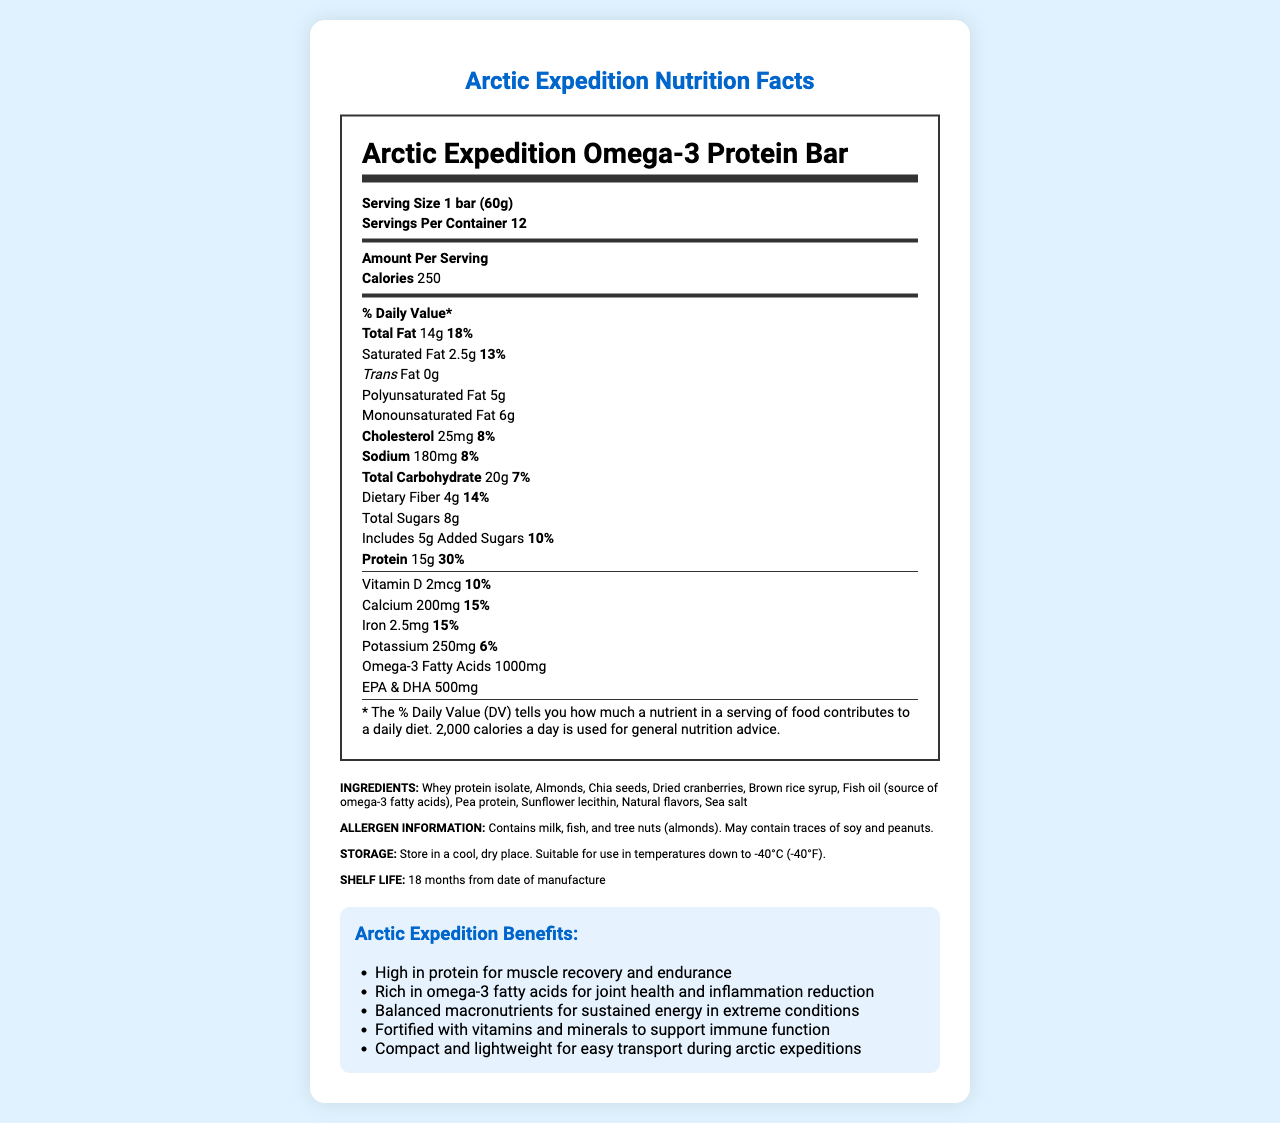what is the serving size of the Arctic Expedition Omega-3 Protein Bar? The serving size is specified right at the top of the nutrition label under the product name.
Answer: 1 bar (60g) how many servings are there per container? The number of servings per container is explicitly noted near the serving size on the nutrition label.
Answer: 12 how many calories are in one serving? The calories per serving are listed under the "Amount Per Serving" section.
Answer: 250 what is the amount of protein in a single protein bar? The protein amount is provided in the "Amount Per Serving" section and is indicated as 15g.
Answer: 15g what is the shelf life of the Arctic Expedition Omega-3 Protein Bar? The shelf life is stated in the storage and shelf life section of the document.
Answer: 18 months from date of manufacture which of the following is NOT an ingredient in the protein bar? A. Almonds B. Chia seeds C. Peanuts D. Dried cranberries The ingredients list includes almonds, chia seeds, and dried cranberries, but not peanuts.
Answer: C. Peanuts how much omega-3 fatty acids does one bar contain? The amount of omega-3 fatty acids is listed in the nutrition label under the "Amount Per Serving" section.
Answer: 1000mg what is the main source of omega-3 fatty acids in the bar? A. Chia seeds B. Fish oil C. Almonds D. Pea protein Fish oil is explicitly mentioned as the source of omega-3 fatty acids in the ingredients list.
Answer: B. Fish oil can this protein bar be stored in temperatures as low as -40°C? The storage instructions specify that the bar is suitable for use in temperatures down to -40°C.
Answer: Yes is this protein bar suitable for someone with a tree nut allergy? The allergen information indicates that the product contains tree nuts (almonds), making it unsuitable for someone with a tree nut allergy.
Answer: No summarize the main features of the Arctic Expedition Omega-3 Protein Bar as presented in the document. The document provides comprehensive information about the product's nutritional content, ingredients, shelf life, storage instructions, and allergen information, emphasizing its suitability for harsh arctic conditions and benefits such as muscle recovery, sustained energy, and inflammation reduction.
Answer: The Arctic Expedition Omega-3 Protein Bar is designed for arctic expeditions, offering a rich source of protein (15g per bar) and omega-3 fatty acids (1000mg per bar). It includes a balanced macronutrient profile, dietary fiber, and is fortified with vitamins and minerals to support immune function. The bar is made of whey protein isolate, almonds, chia seeds, dried cranberries, and fish oil. It is suitable for extreme temperatures down to -40°C and has a shelf life of 18 months. The product also contains allergens such as milk, fish, and tree nuts. how many grams of dietary fiber are in one serving? The amount of dietary fiber per serving is listed in the nutrition label.
Answer: 4g which of the following benefits is NOT mentioned in the document? A. High in protein for muscle recovery B. Rich in antioxidants C. Balanced macronutrients for energy D. Fortified with vitamins and minerals The benefits section of the document does not mention antioxidants; it does, however, list benefits related to protein, macronutrients, and vitamins and minerals.
Answer: B. Rich in antioxidants are there any trans fats in the protein bar? The document specifies that the protein bar contains 0g of trans fats.
Answer: No is the daily value of monounsaturated fats specified in the document? While the amount of monounsaturated fat (6g) is specified, its daily value percentage is not provided.
Answer: No 